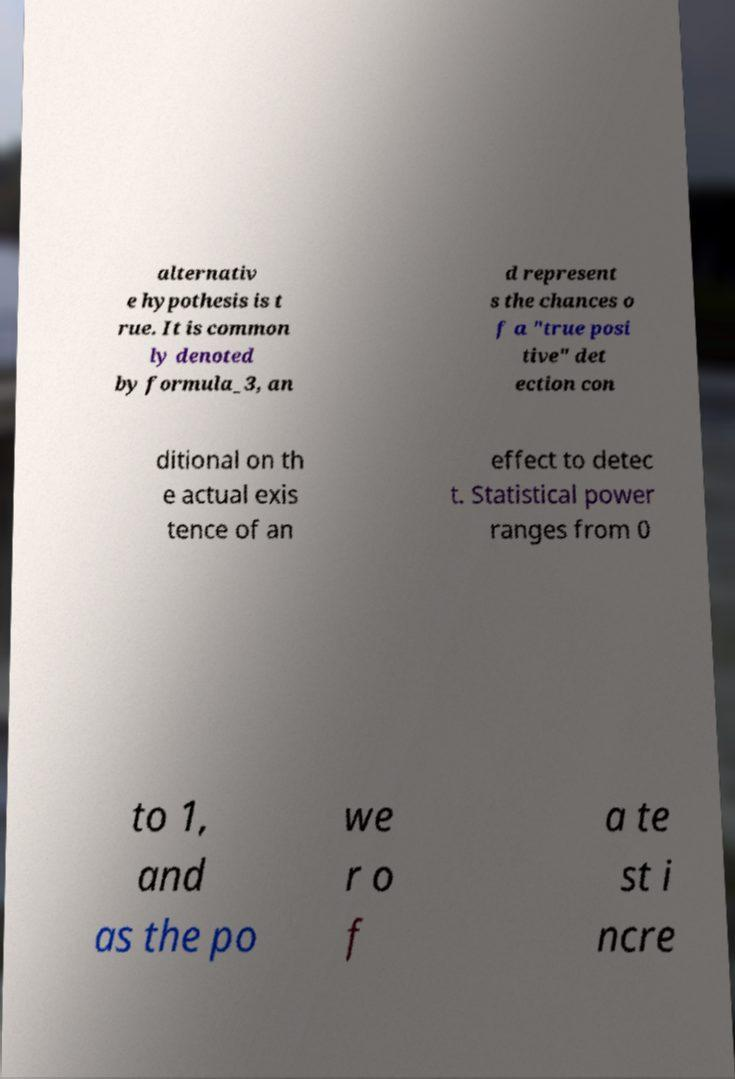Could you extract and type out the text from this image? alternativ e hypothesis is t rue. It is common ly denoted by formula_3, an d represent s the chances o f a "true posi tive" det ection con ditional on th e actual exis tence of an effect to detec t. Statistical power ranges from 0 to 1, and as the po we r o f a te st i ncre 